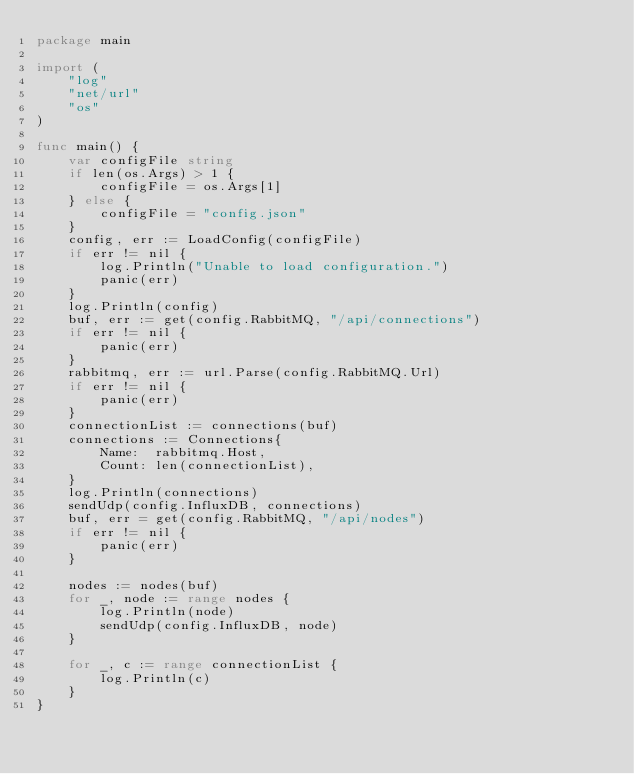<code> <loc_0><loc_0><loc_500><loc_500><_Go_>package main

import (
	"log"
	"net/url"
	"os"
)

func main() {
	var configFile string
	if len(os.Args) > 1 {
		configFile = os.Args[1]
	} else {
		configFile = "config.json"
	}
	config, err := LoadConfig(configFile)
	if err != nil {
		log.Println("Unable to load configuration.")
		panic(err)
	}
	log.Println(config)
	buf, err := get(config.RabbitMQ, "/api/connections")
	if err != nil {
		panic(err)
	}
	rabbitmq, err := url.Parse(config.RabbitMQ.Url)
	if err != nil {
		panic(err)
	}
	connectionList := connections(buf)
	connections := Connections{
		Name:  rabbitmq.Host,
		Count: len(connectionList),
	}
	log.Println(connections)
	sendUdp(config.InfluxDB, connections)
	buf, err = get(config.RabbitMQ, "/api/nodes")
	if err != nil {
		panic(err)
	}

	nodes := nodes(buf)
	for _, node := range nodes {
		log.Println(node)
		sendUdp(config.InfluxDB, node)
	}
	
	for _, c := range connectionList {
		log.Println(c)
	}
}
</code> 